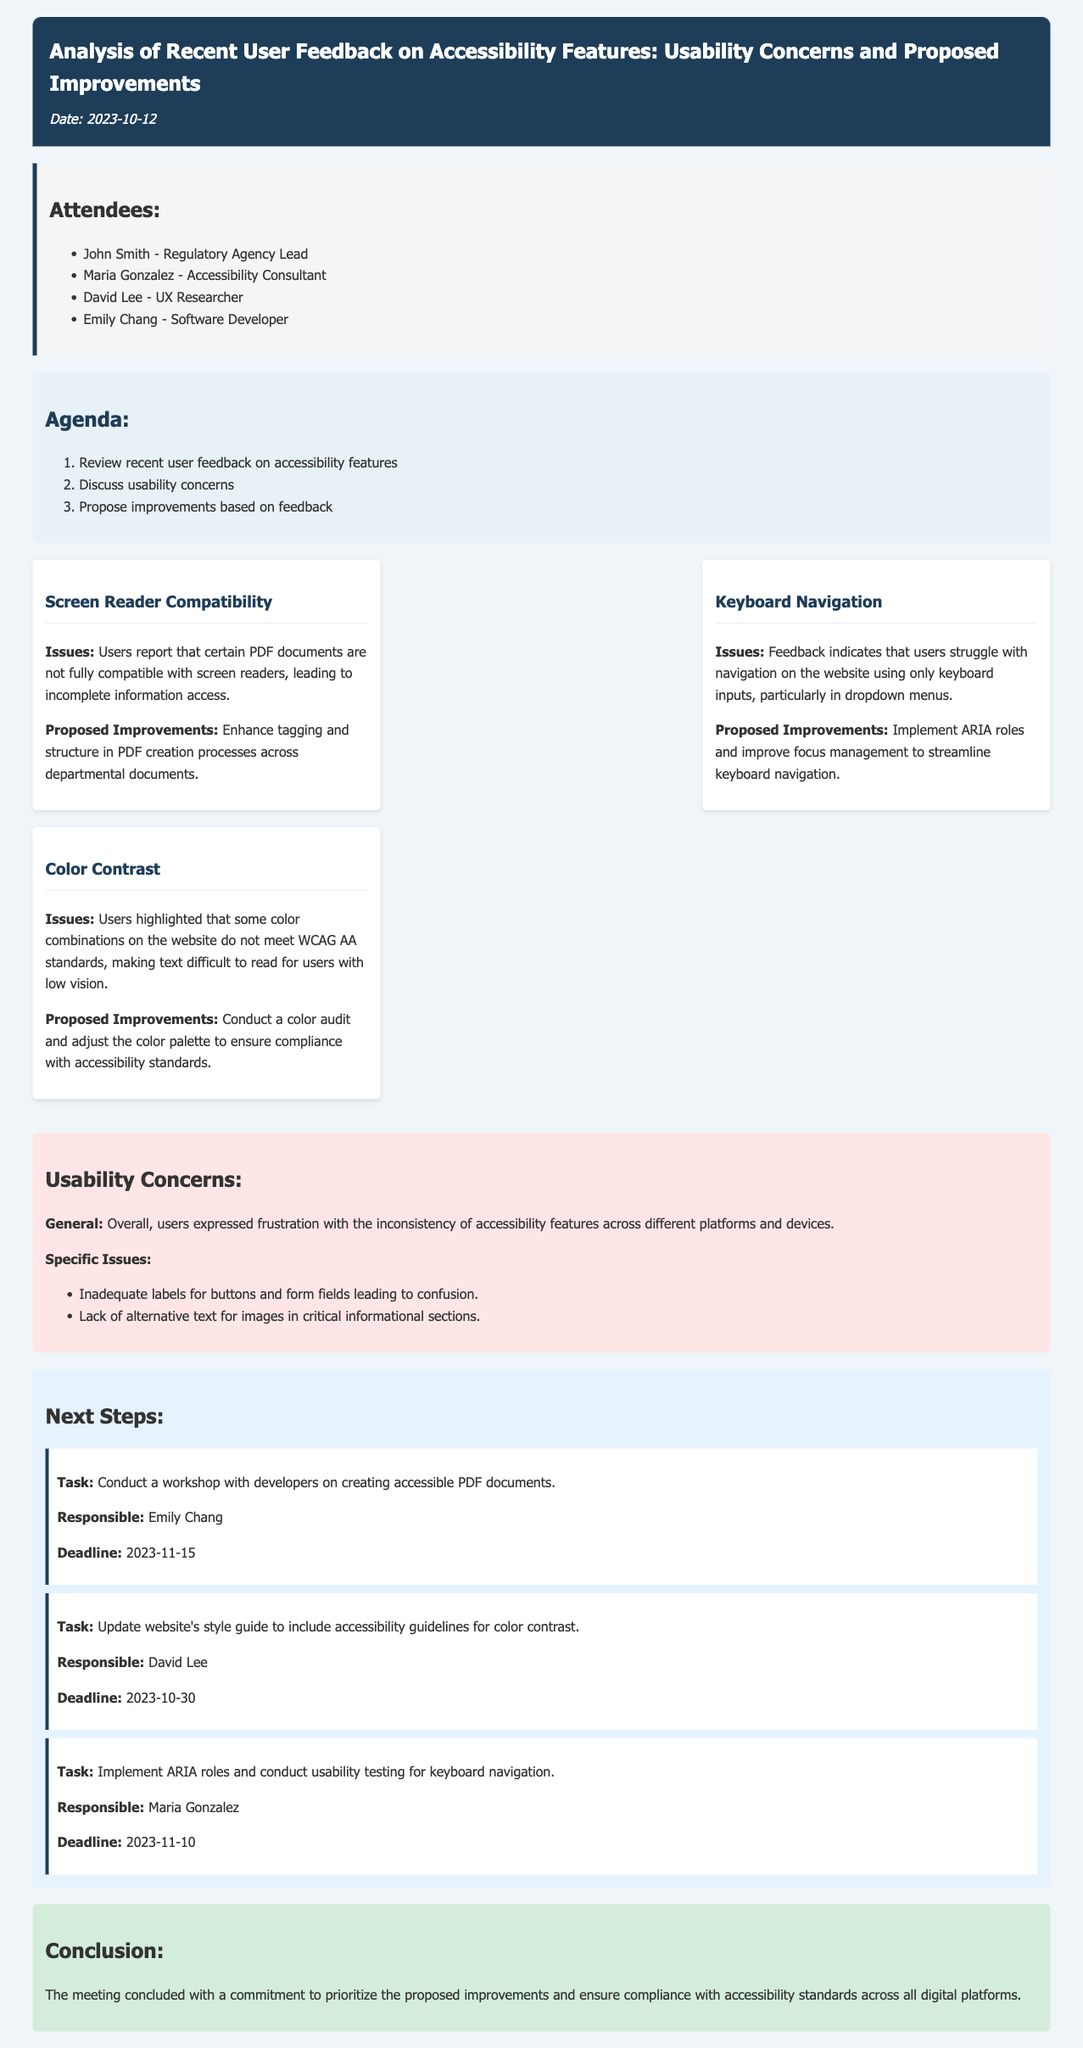What is the date of the meeting? The date of the meeting is provided in the document header.
Answer: 2023-10-12 Who is responsible for conducting the workshop on accessible PDF documents? The document lists specific responsibilities for each task under the next steps section.
Answer: Emily Chang What issue is related to keyboard navigation? The findings section mentions specific issues encountered by users; categorizing these issues helps to identify usability concerns.
Answer: Struggle with navigation using only keyboard inputs Which standard do some color combinations fail to meet? The usability concerns include references to compliance standards, specifically for color contrasts.
Answer: WCAG AA standards What is one proposed improvement for screen reader compatibility? Proposed improvements are given alongside each issue identified in the findings section of the document.
Answer: Enhance tagging and structure in PDF creation processes What deadline is set for updating the website's style guide? The deadlines for action items are specified next to the responsible persons in the next steps section.
Answer: 2023-10-30 What was a general usability concern expressed by users? The document summarizes the overall user feedback and frustrations in the usability concerns section.
Answer: Inconsistency of accessibility features across different platforms How many attendees were listed for the meeting? The attendees are clearly outlined in a list format within the document.
Answer: Four 